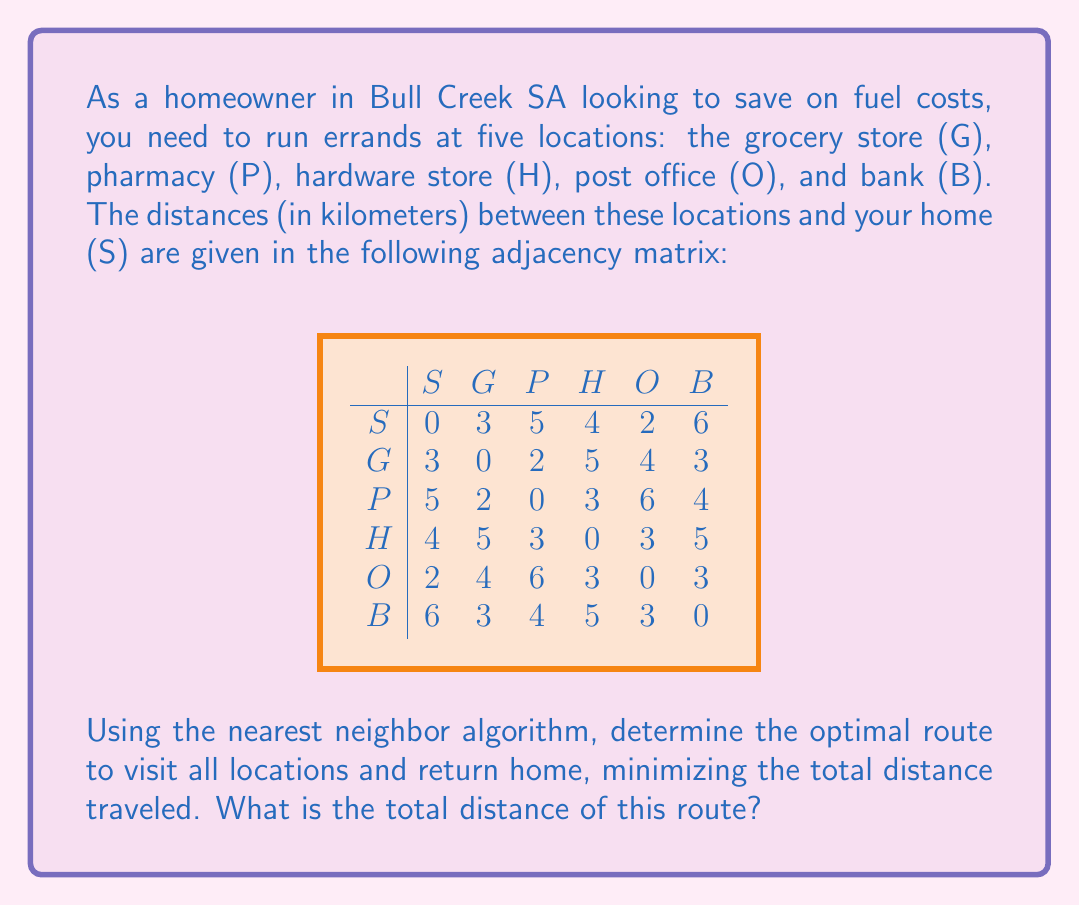Teach me how to tackle this problem. To solve this problem, we'll use the nearest neighbor algorithm, which is a greedy approach to solving the Traveling Salesman Problem. Here's how we'll proceed:

1) Start at home (S).
2) Find the nearest unvisited location.
3) Move to that location.
4) Repeat steps 2-3 until all locations are visited.
5) Return home.

Let's follow the algorithm step by step:

1) Start at S (0 km traveled)

2) Nearest to S is O (2 km)
   Route: S → O
   Distance: 0 + 2 = 2 km

3) Nearest to O (excluding S) is B (3 km)
   Route: S → O → B
   Distance: 2 + 3 = 5 km

4) Nearest to B (excluding S and O) is G (3 km)
   Route: S → O → B → G
   Distance: 5 + 3 = 8 km

5) Nearest to G (excluding S, O, and B) is P (2 km)
   Route: S → O → B → G → P
   Distance: 8 + 2 = 10 km

6) Only H remains, so we go there (3 km from P)
   Route: S → O → B → G → P → H
   Distance: 10 + 3 = 13 km

7) Finally, return home from H (4 km)
   Complete route: S → O → B → G → P → H → S
   Total distance: 13 + 4 = 17 km

Therefore, the optimal route according to the nearest neighbor algorithm is:
S → O → B → G → P → H → S, with a total distance of 17 km.
Answer: 17 km 